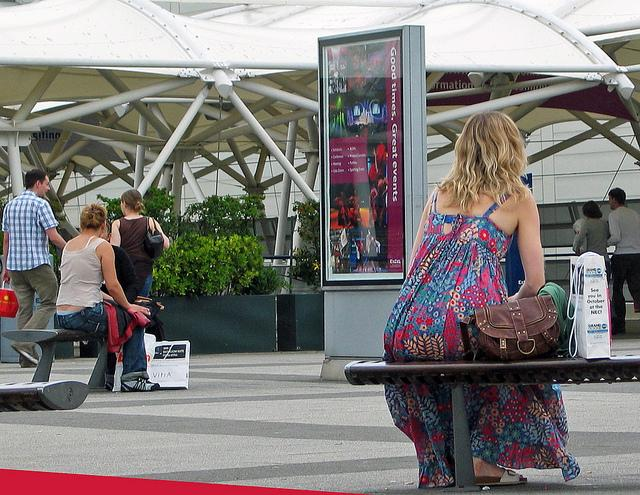What color is the leather of the woman's purse who is sitting on the bench to the right?

Choices:
A) white
B) black
C) cream
D) tan tan 